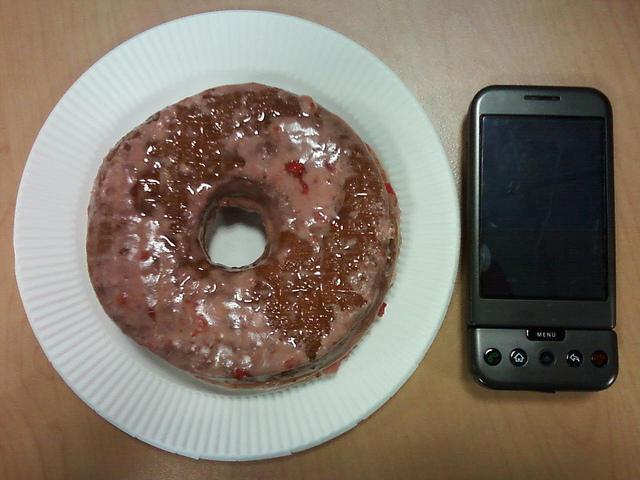Does the description: "The donut is on the dining table." accurately reflect the image?
Answer yes or no. Yes. 